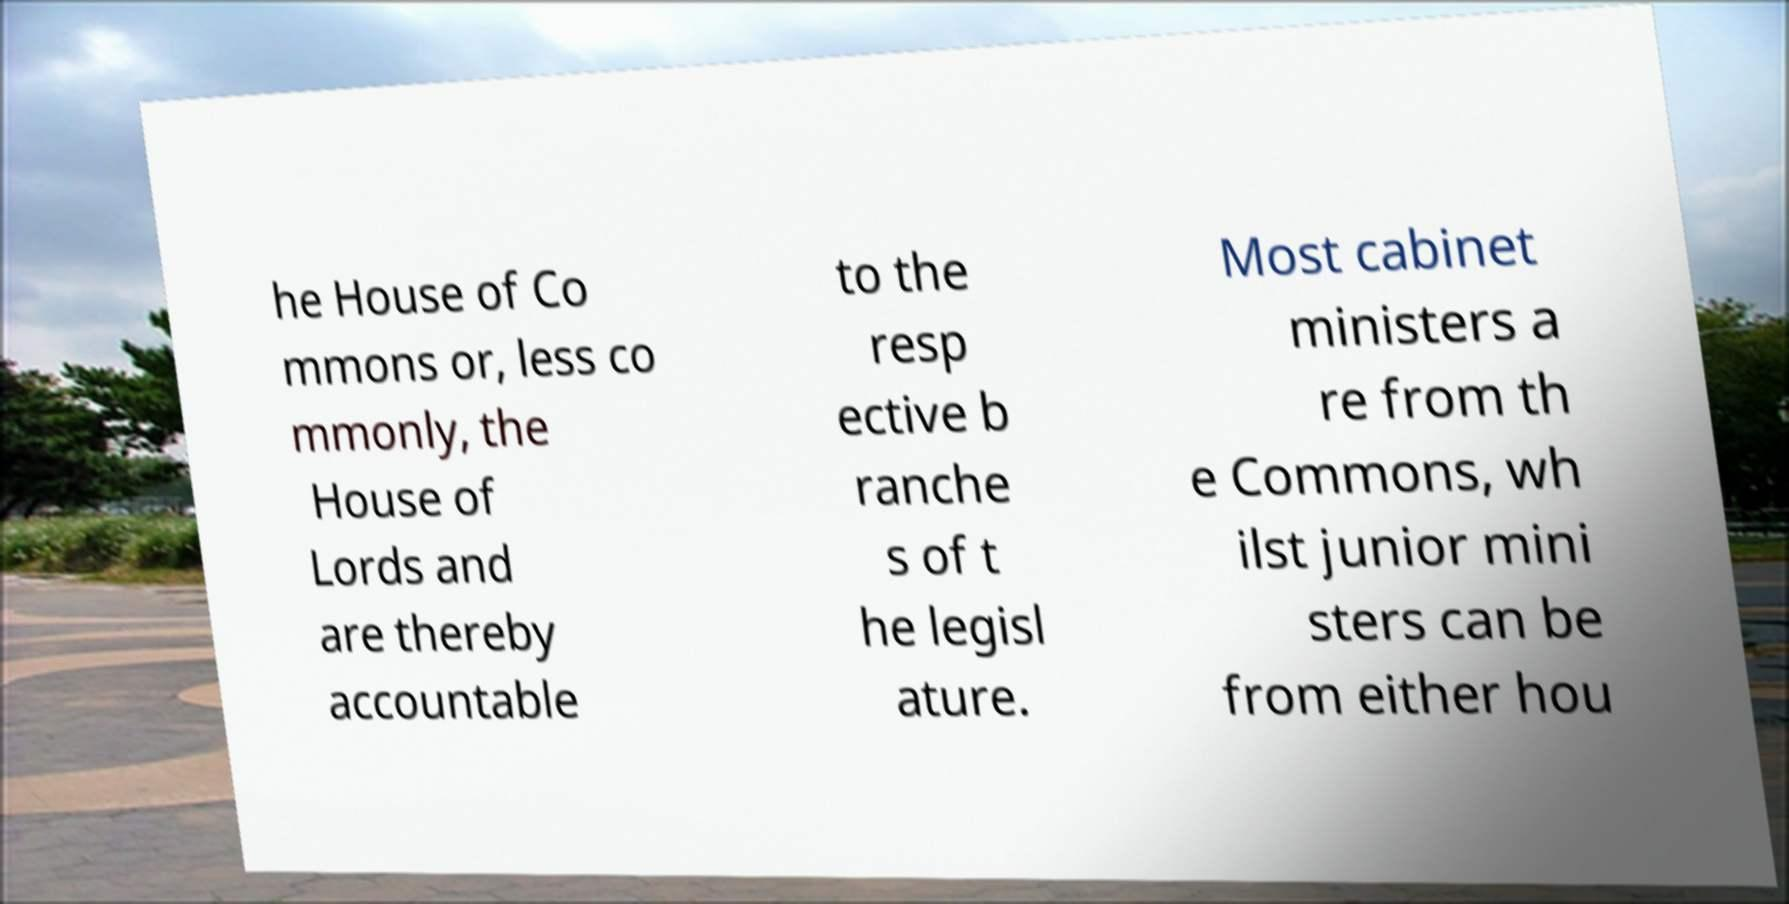Can you read and provide the text displayed in the image?This photo seems to have some interesting text. Can you extract and type it out for me? he House of Co mmons or, less co mmonly, the House of Lords and are thereby accountable to the resp ective b ranche s of t he legisl ature. Most cabinet ministers a re from th e Commons, wh ilst junior mini sters can be from either hou 